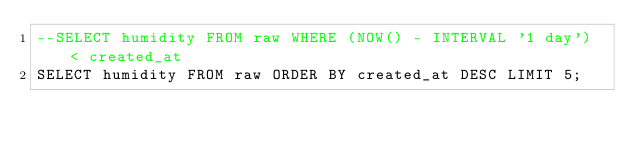Convert code to text. <code><loc_0><loc_0><loc_500><loc_500><_SQL_>--SELECT humidity FROM raw WHERE (NOW() - INTERVAL '1 day') < created_at
SELECT humidity FROM raw ORDER BY created_at DESC LIMIT 5;
</code> 